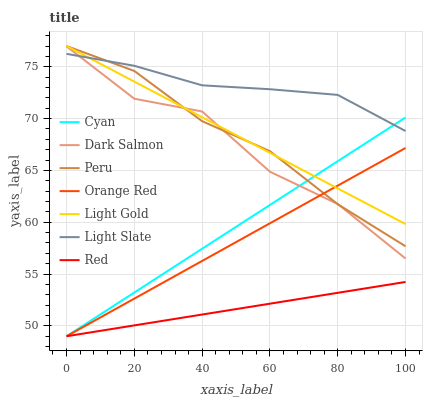Does Red have the minimum area under the curve?
Answer yes or no. Yes. Does Light Slate have the maximum area under the curve?
Answer yes or no. Yes. Does Dark Salmon have the minimum area under the curve?
Answer yes or no. No. Does Dark Salmon have the maximum area under the curve?
Answer yes or no. No. Is Light Gold the smoothest?
Answer yes or no. Yes. Is Dark Salmon the roughest?
Answer yes or no. Yes. Is Peru the smoothest?
Answer yes or no. No. Is Peru the roughest?
Answer yes or no. No. Does Dark Salmon have the lowest value?
Answer yes or no. No. Does Light Gold have the highest value?
Answer yes or no. Yes. Does Dark Salmon have the highest value?
Answer yes or no. No. Is Red less than Light Slate?
Answer yes or no. Yes. Is Light Slate greater than Red?
Answer yes or no. Yes. Does Red intersect Light Slate?
Answer yes or no. No. 